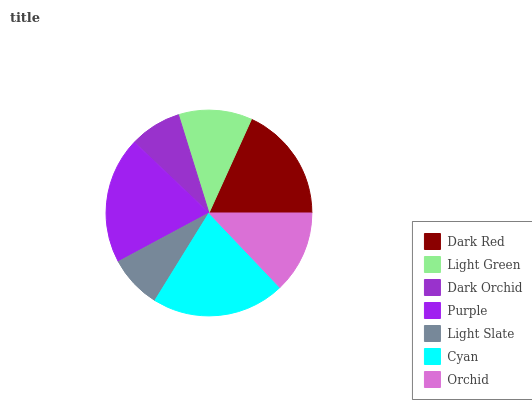Is Dark Orchid the minimum?
Answer yes or no. Yes. Is Cyan the maximum?
Answer yes or no. Yes. Is Light Green the minimum?
Answer yes or no. No. Is Light Green the maximum?
Answer yes or no. No. Is Dark Red greater than Light Green?
Answer yes or no. Yes. Is Light Green less than Dark Red?
Answer yes or no. Yes. Is Light Green greater than Dark Red?
Answer yes or no. No. Is Dark Red less than Light Green?
Answer yes or no. No. Is Orchid the high median?
Answer yes or no. Yes. Is Orchid the low median?
Answer yes or no. Yes. Is Light Slate the high median?
Answer yes or no. No. Is Light Slate the low median?
Answer yes or no. No. 